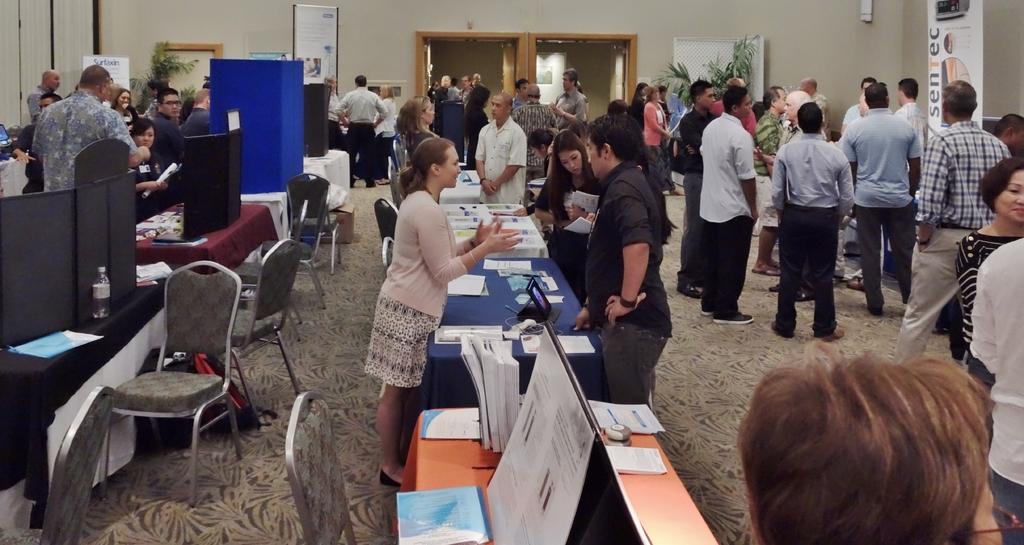Describe this image in one or two sentences. This picture describes about group of people few are seated on the chair and few are standing and we can find papers, bottle, books, mobile on the table, and also we can find a plant and hoardings. 